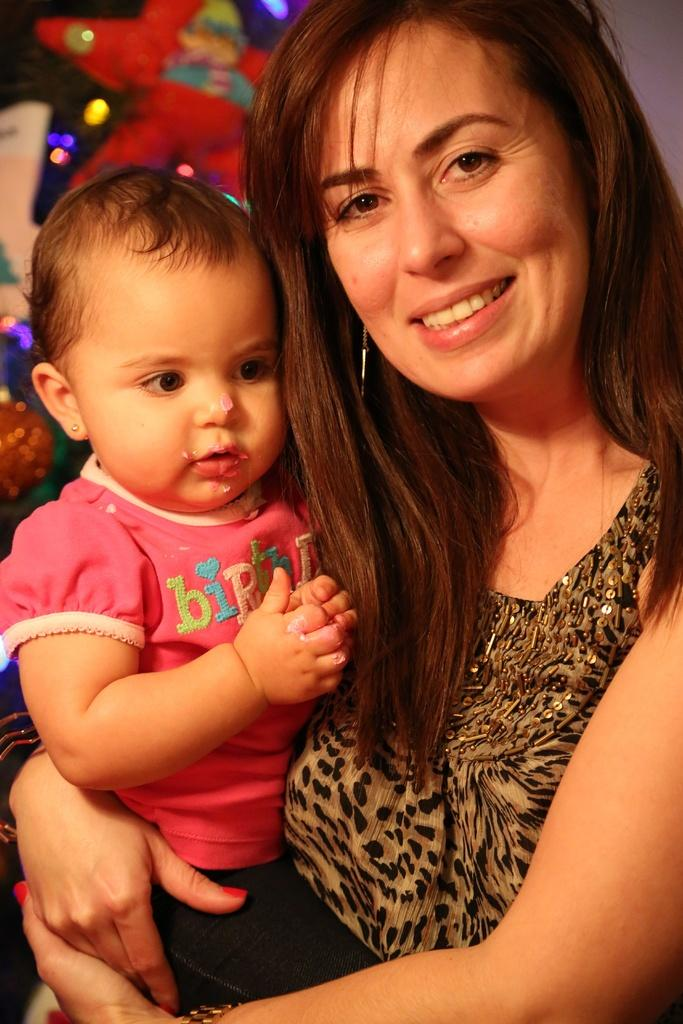What is the main subject of the image? There is a person in the image. What is the person wearing? The person is wearing clothes. What is the person doing in the image? The person is holding a baby with her hands. What type of property is visible in the background of the image? There is no property visible in the background of the image. Is the person wearing a mask in the image? There is no mention of a mask in the image, and the person is not wearing one. 